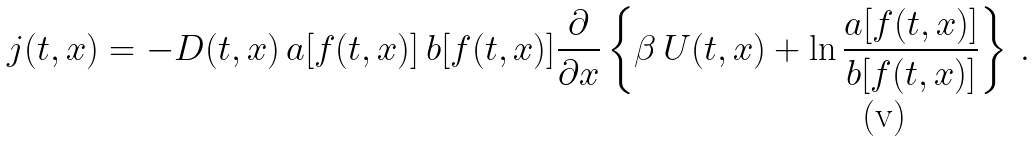<formula> <loc_0><loc_0><loc_500><loc_500>j ( t , x ) = - D ( t , x ) \, a [ f ( t , x ) ] \, b [ f ( t , x ) ] \frac { \partial } { \partial x } \left \{ \beta \, U ( t , x ) + \ln \frac { a [ f ( t , x ) ] } { b [ f ( t , x ) ] } \right \} \, .</formula> 